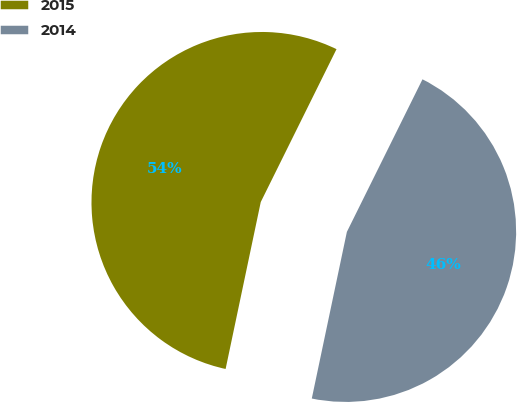<chart> <loc_0><loc_0><loc_500><loc_500><pie_chart><fcel>2015<fcel>2014<nl><fcel>54.02%<fcel>45.98%<nl></chart> 